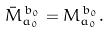<formula> <loc_0><loc_0><loc_500><loc_500>\bar { M } _ { a _ { 0 } } ^ { \, b _ { 0 } } = M _ { a _ { 0 } } ^ { \, b _ { 0 } } .</formula> 